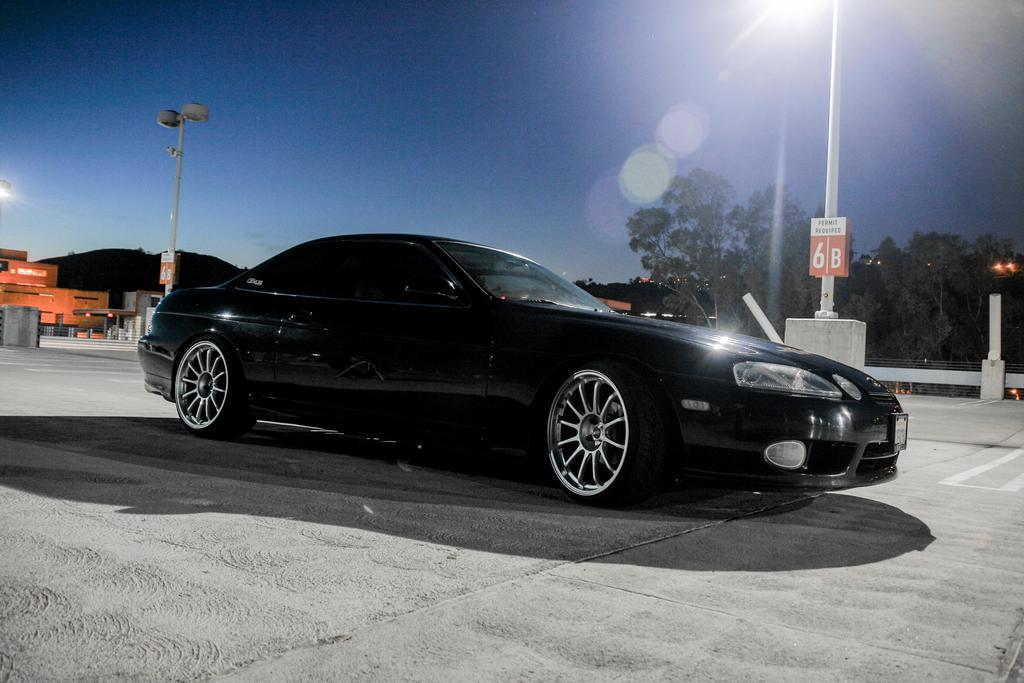In one or two sentences, can you explain what this image depicts? In this image I can see on the left side it looks like a building, in the middle there is a car in black color. On the right side there are trees. at the top there is a light and there is the sky. 